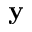<formula> <loc_0><loc_0><loc_500><loc_500>y</formula> 